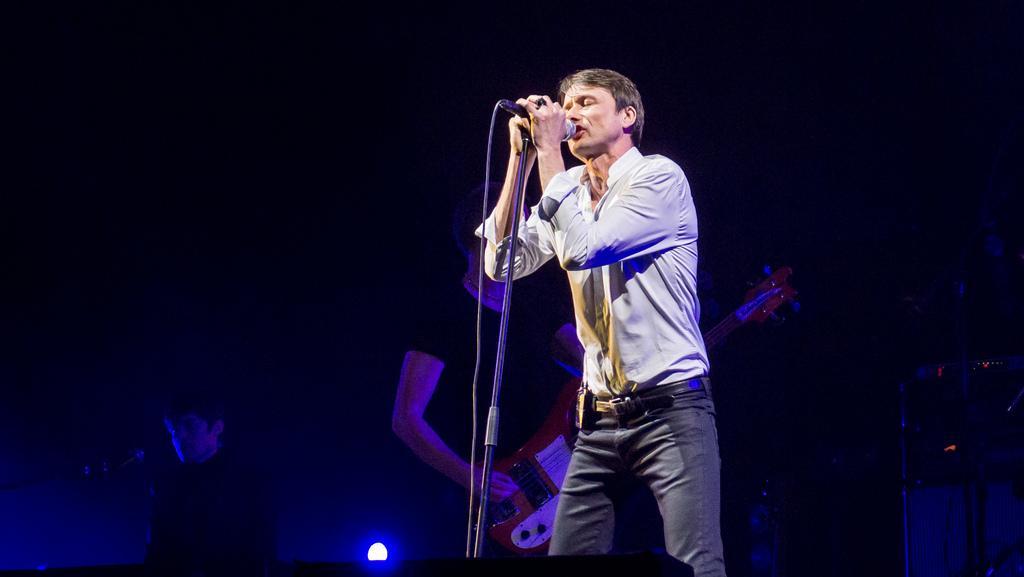In one or two sentences, can you explain what this image depicts? In the image I can see a person standing on the stage and singing in a microphone, behind him there is another man standing and playing musical instrument. 